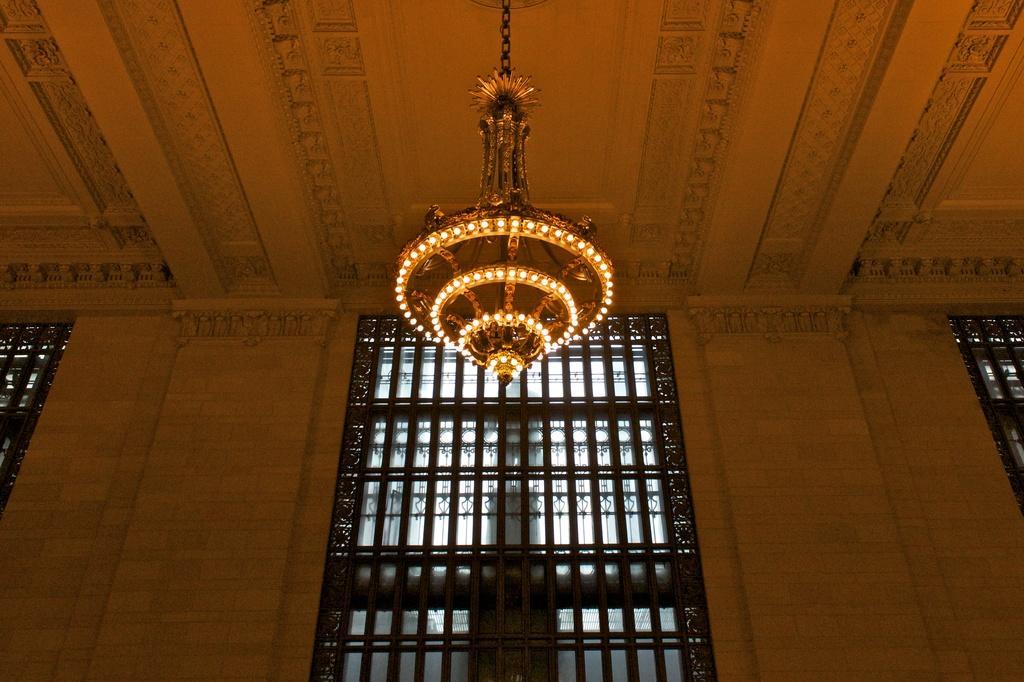Describe this image in one or two sentences. We can see chandelier and we can see wall and windows. 